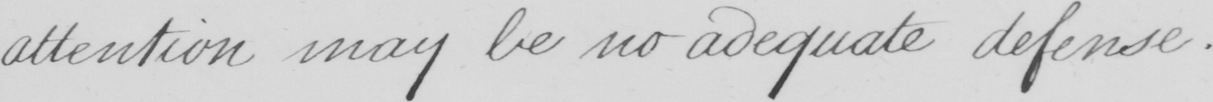Please provide the text content of this handwritten line. attention may be no adequate defense . 